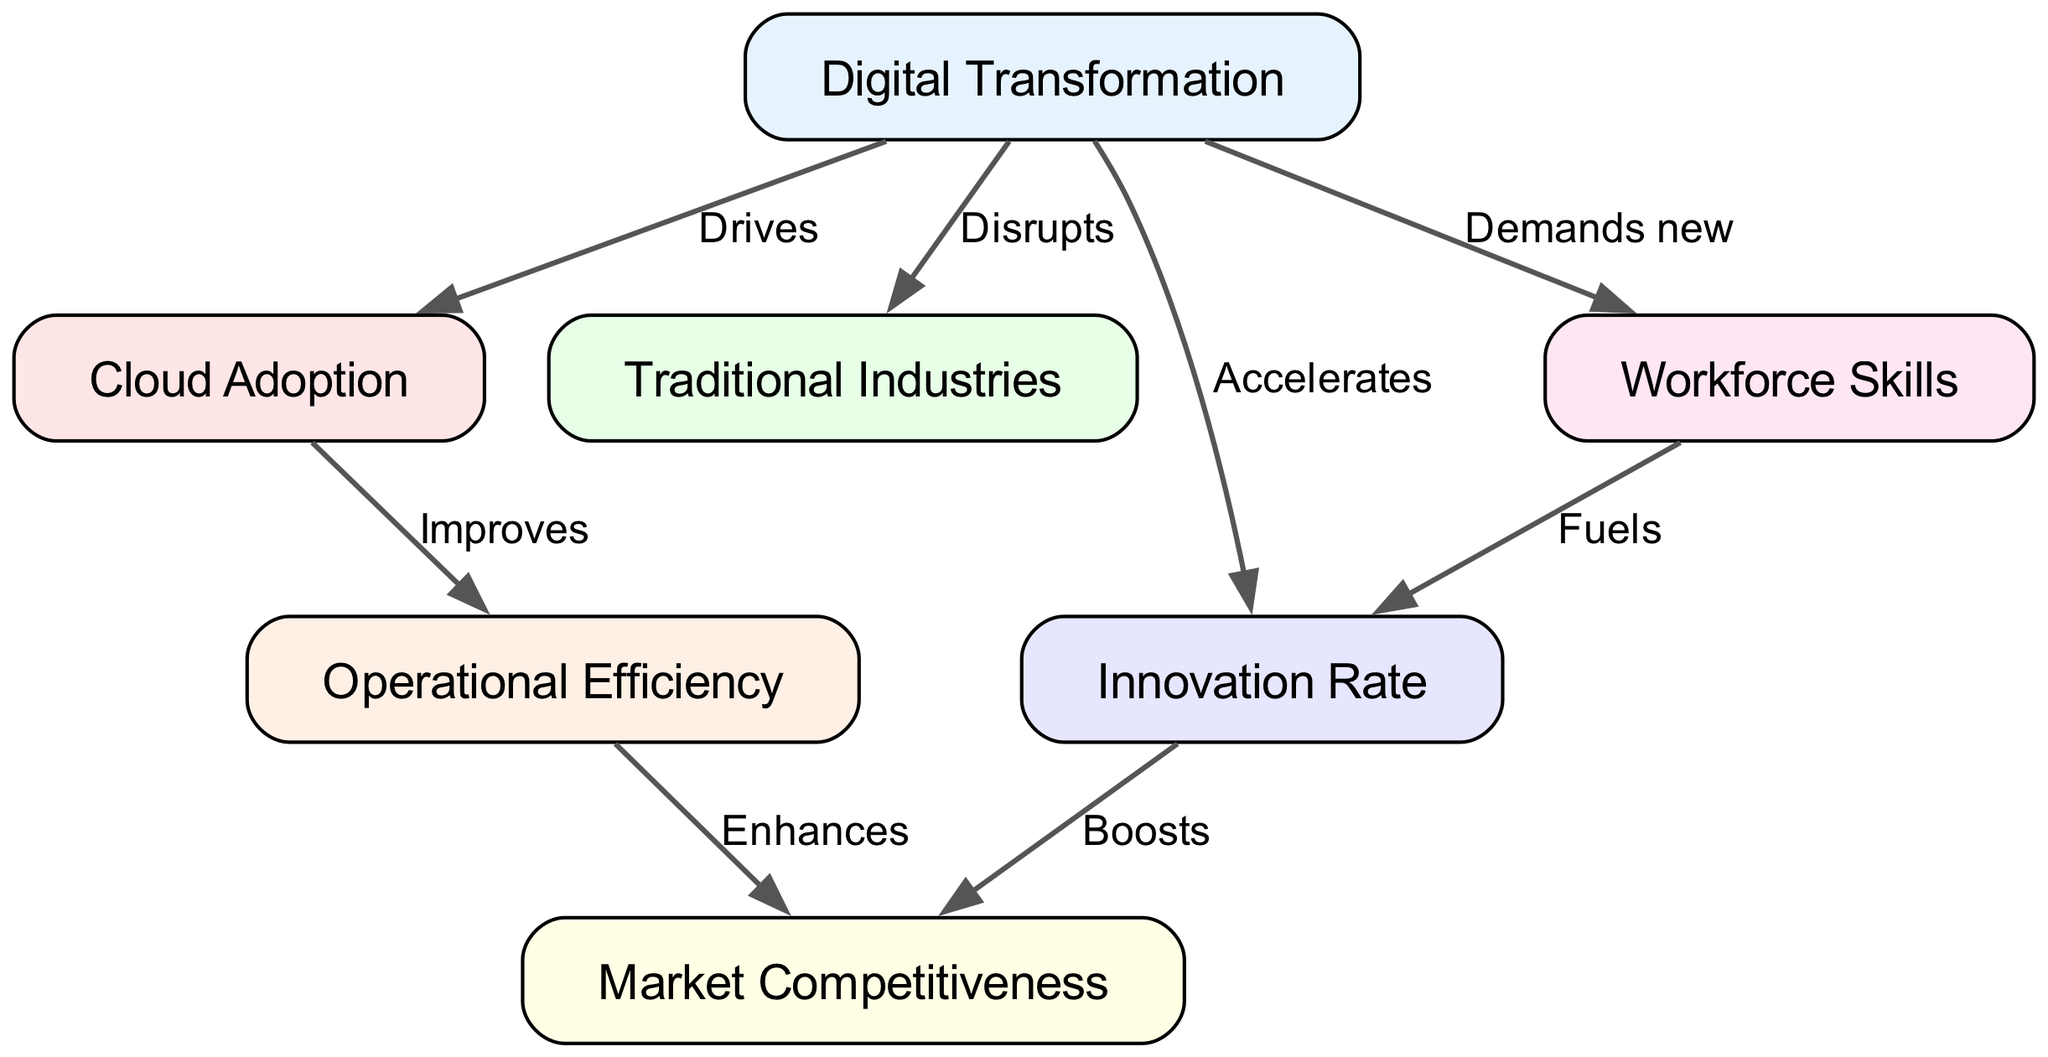What are the total number of nodes in the diagram? The diagram contains several distinct elements that represent different concepts. By counting the provided nodes: Digital Transformation, Cloud Adoption, Traditional Industries, Operational Efficiency, Innovation Rate, Market Competitiveness, and Workforce Skills, we find there are 7 nodes in total.
Answer: 7 What does Digital Transformation do to Traditional Industries? The relationship indicated in the diagram shows that Digital Transformation disrupts Traditional Industries. Thus, the impact of Digital Transformation on Traditional Industries is represented by the word "Disrupts."
Answer: Disrupts How does Cloud Adoption affect Operational Efficiency? The diagram clearly indicates that Cloud Adoption improves Operational Efficiency. Thus, the relationship from Cloud Adoption to Operational Efficiency is labeled as "Improves."
Answer: Improves What is the relationship between Innovation Rate and Market Competitiveness? Looking at the diagram, we observe that Innovation Rate boosts Market Competitiveness. This connection shows that there is a direct positive impact from the rate of innovation on how competitive a market can be.
Answer: Boosts What drives Cloud Adoption? According to the diagram, the factor that drives Cloud Adoption is Digital Transformation. This indicates that the process of digital transformation encourages industries to adopt cloud technologies.
Answer: Digital Transformation What impacts does Digital Transformation have on Workforce Skills? In the diagram, it states that Digital Transformation demands new Workforce Skills. This implies that as industries go through digital transformation, they require their workforce to acquire new skills.
Answer: Demands new Explain the flow from Digital Transformation to Market Competitiveness. The flow starts from Digital Transformation, which then accelerates Innovation Rate. The Innovation Rate subsequently boosts Market Competitiveness. Additionally, Digital Transformation also improves Operational Efficiency, which enhances Market Competitiveness. Therefore, the effect on Market Competitiveness arises from multiple interlinked influences, ultimately showing that Digital Transformation has a multifaceted impact.
Answer: Multifaceted impact through innovation and efficiency 